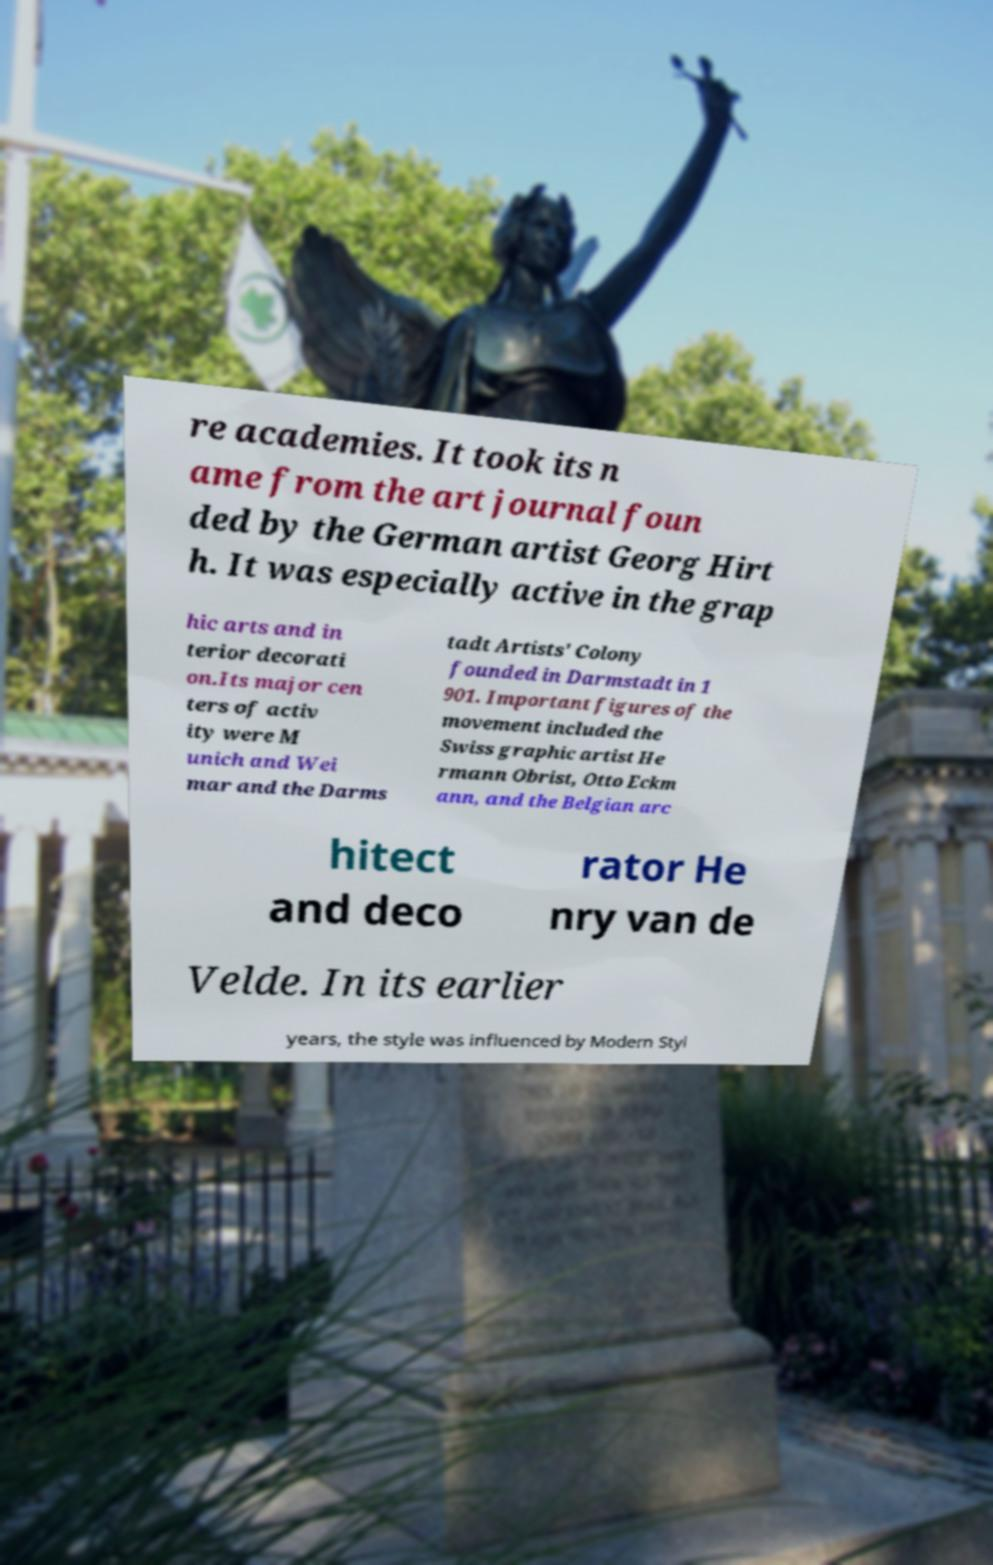For documentation purposes, I need the text within this image transcribed. Could you provide that? re academies. It took its n ame from the art journal foun ded by the German artist Georg Hirt h. It was especially active in the grap hic arts and in terior decorati on.Its major cen ters of activ ity were M unich and Wei mar and the Darms tadt Artists' Colony founded in Darmstadt in 1 901. Important figures of the movement included the Swiss graphic artist He rmann Obrist, Otto Eckm ann, and the Belgian arc hitect and deco rator He nry van de Velde. In its earlier years, the style was influenced by Modern Styl 